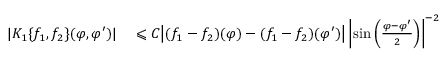Convert formula to latex. <formula><loc_0><loc_0><loc_500><loc_500>\begin{array} { r l } { | K _ { 1 } \{ f _ { 1 } , f _ { 2 } \} ( \varphi , \varphi ^ { \prime } ) | } & \leqslant C \left | ( f _ { 1 } - f _ { 2 } ) ( \varphi ) - ( f _ { 1 } - f _ { 2 } ) ( \varphi ^ { \prime } ) \right | \left | \sin \left ( \frac { \varphi - \varphi ^ { \prime } } { 2 } \right ) \right | ^ { - 2 } } \end{array}</formula> 